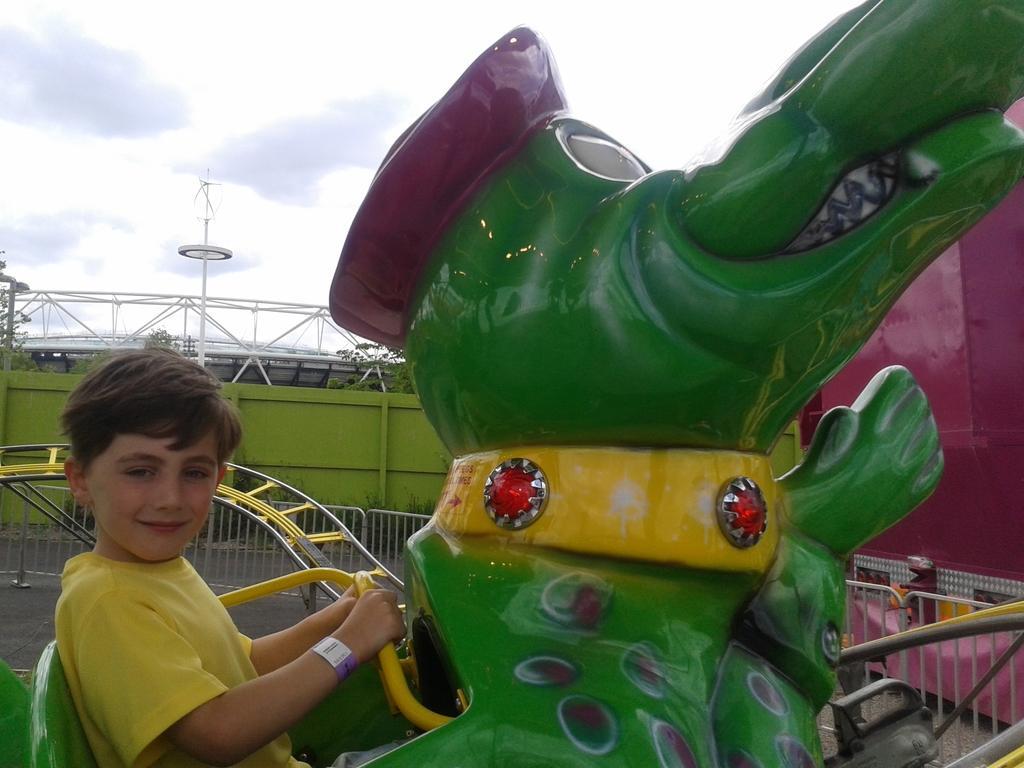Describe this image in one or two sentences. In this image there is a child sitting on the roller coaster, behind the child there is a railing, planter, fencing and in the background there are some metal structures and the sky. 